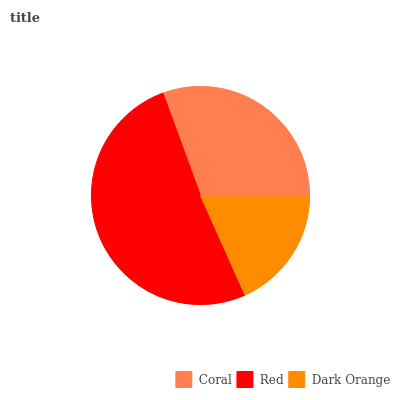Is Dark Orange the minimum?
Answer yes or no. Yes. Is Red the maximum?
Answer yes or no. Yes. Is Red the minimum?
Answer yes or no. No. Is Dark Orange the maximum?
Answer yes or no. No. Is Red greater than Dark Orange?
Answer yes or no. Yes. Is Dark Orange less than Red?
Answer yes or no. Yes. Is Dark Orange greater than Red?
Answer yes or no. No. Is Red less than Dark Orange?
Answer yes or no. No. Is Coral the high median?
Answer yes or no. Yes. Is Coral the low median?
Answer yes or no. Yes. Is Red the high median?
Answer yes or no. No. Is Red the low median?
Answer yes or no. No. 